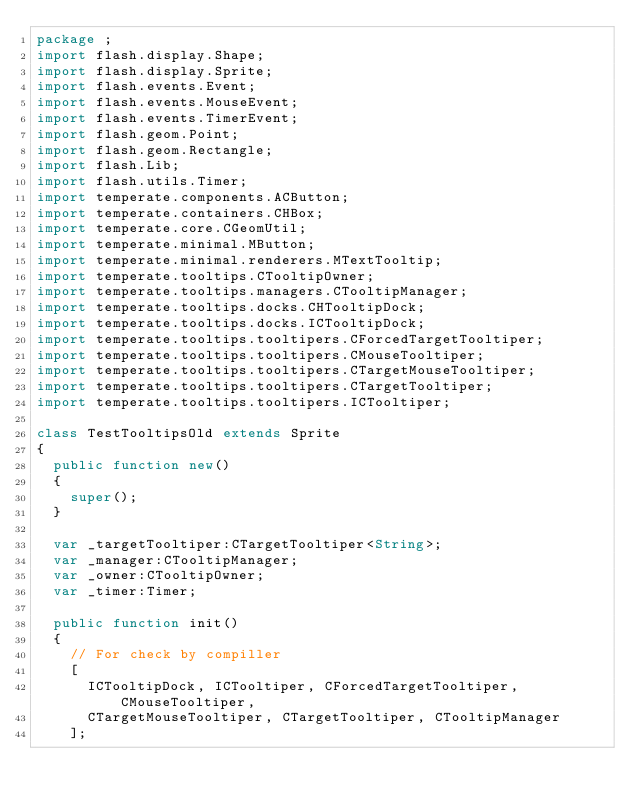Convert code to text. <code><loc_0><loc_0><loc_500><loc_500><_Haxe_>package ;
import flash.display.Shape;
import flash.display.Sprite;
import flash.events.Event;
import flash.events.MouseEvent;
import flash.events.TimerEvent;
import flash.geom.Point;
import flash.geom.Rectangle;
import flash.Lib;
import flash.utils.Timer;
import temperate.components.ACButton;
import temperate.containers.CHBox;
import temperate.core.CGeomUtil;
import temperate.minimal.MButton;
import temperate.minimal.renderers.MTextTooltip;
import temperate.tooltips.CTooltipOwner;
import temperate.tooltips.managers.CTooltipManager;
import temperate.tooltips.docks.CHTooltipDock;
import temperate.tooltips.docks.ICTooltipDock;
import temperate.tooltips.tooltipers.CForcedTargetTooltiper;
import temperate.tooltips.tooltipers.CMouseTooltiper;
import temperate.tooltips.tooltipers.CTargetMouseTooltiper;
import temperate.tooltips.tooltipers.CTargetTooltiper;
import temperate.tooltips.tooltipers.ICTooltiper;

class TestTooltipsOld extends Sprite
{
	public function new() 
	{
		super();
	}
	
	var _targetTooltiper:CTargetTooltiper<String>;
	var _manager:CTooltipManager;
	var _owner:CTooltipOwner;
	var _timer:Timer;
	
	public function init()
	{
		// For check by compiller
		[ 
			ICTooltipDock, ICTooltiper, CForcedTargetTooltiper, CMouseTooltiper,
			CTargetMouseTooltiper, CTargetTooltiper, CTooltipManager
		];
		</code> 